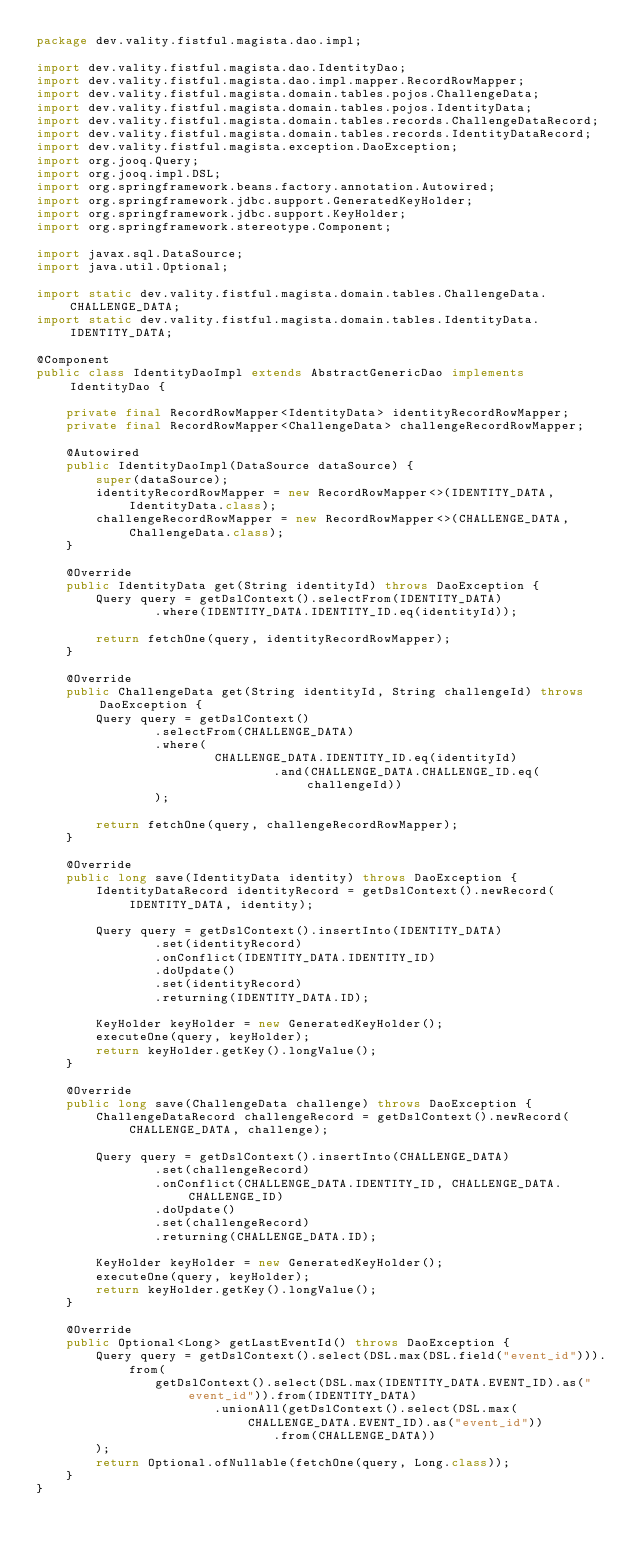<code> <loc_0><loc_0><loc_500><loc_500><_Java_>package dev.vality.fistful.magista.dao.impl;

import dev.vality.fistful.magista.dao.IdentityDao;
import dev.vality.fistful.magista.dao.impl.mapper.RecordRowMapper;
import dev.vality.fistful.magista.domain.tables.pojos.ChallengeData;
import dev.vality.fistful.magista.domain.tables.pojos.IdentityData;
import dev.vality.fistful.magista.domain.tables.records.ChallengeDataRecord;
import dev.vality.fistful.magista.domain.tables.records.IdentityDataRecord;
import dev.vality.fistful.magista.exception.DaoException;
import org.jooq.Query;
import org.jooq.impl.DSL;
import org.springframework.beans.factory.annotation.Autowired;
import org.springframework.jdbc.support.GeneratedKeyHolder;
import org.springframework.jdbc.support.KeyHolder;
import org.springframework.stereotype.Component;

import javax.sql.DataSource;
import java.util.Optional;

import static dev.vality.fistful.magista.domain.tables.ChallengeData.CHALLENGE_DATA;
import static dev.vality.fistful.magista.domain.tables.IdentityData.IDENTITY_DATA;

@Component
public class IdentityDaoImpl extends AbstractGenericDao implements IdentityDao {

    private final RecordRowMapper<IdentityData> identityRecordRowMapper;
    private final RecordRowMapper<ChallengeData> challengeRecordRowMapper;

    @Autowired
    public IdentityDaoImpl(DataSource dataSource) {
        super(dataSource);
        identityRecordRowMapper = new RecordRowMapper<>(IDENTITY_DATA, IdentityData.class);
        challengeRecordRowMapper = new RecordRowMapper<>(CHALLENGE_DATA, ChallengeData.class);
    }

    @Override
    public IdentityData get(String identityId) throws DaoException {
        Query query = getDslContext().selectFrom(IDENTITY_DATA)
                .where(IDENTITY_DATA.IDENTITY_ID.eq(identityId));

        return fetchOne(query, identityRecordRowMapper);
    }

    @Override
    public ChallengeData get(String identityId, String challengeId) throws DaoException {
        Query query = getDslContext()
                .selectFrom(CHALLENGE_DATA)
                .where(
                        CHALLENGE_DATA.IDENTITY_ID.eq(identityId)
                                .and(CHALLENGE_DATA.CHALLENGE_ID.eq(challengeId))
                );

        return fetchOne(query, challengeRecordRowMapper);
    }

    @Override
    public long save(IdentityData identity) throws DaoException {
        IdentityDataRecord identityRecord = getDslContext().newRecord(IDENTITY_DATA, identity);

        Query query = getDslContext().insertInto(IDENTITY_DATA)
                .set(identityRecord)
                .onConflict(IDENTITY_DATA.IDENTITY_ID)
                .doUpdate()
                .set(identityRecord)
                .returning(IDENTITY_DATA.ID);

        KeyHolder keyHolder = new GeneratedKeyHolder();
        executeOne(query, keyHolder);
        return keyHolder.getKey().longValue();
    }

    @Override
    public long save(ChallengeData challenge) throws DaoException {
        ChallengeDataRecord challengeRecord = getDslContext().newRecord(CHALLENGE_DATA, challenge);

        Query query = getDslContext().insertInto(CHALLENGE_DATA)
                .set(challengeRecord)
                .onConflict(CHALLENGE_DATA.IDENTITY_ID, CHALLENGE_DATA.CHALLENGE_ID)
                .doUpdate()
                .set(challengeRecord)
                .returning(CHALLENGE_DATA.ID);

        KeyHolder keyHolder = new GeneratedKeyHolder();
        executeOne(query, keyHolder);
        return keyHolder.getKey().longValue();
    }

    @Override
    public Optional<Long> getLastEventId() throws DaoException {
        Query query = getDslContext().select(DSL.max(DSL.field("event_id"))).from(
                getDslContext().select(DSL.max(IDENTITY_DATA.EVENT_ID).as("event_id")).from(IDENTITY_DATA)
                        .unionAll(getDslContext().select(DSL.max(CHALLENGE_DATA.EVENT_ID).as("event_id"))
                                .from(CHALLENGE_DATA))
        );
        return Optional.ofNullable(fetchOne(query, Long.class));
    }
}
</code> 